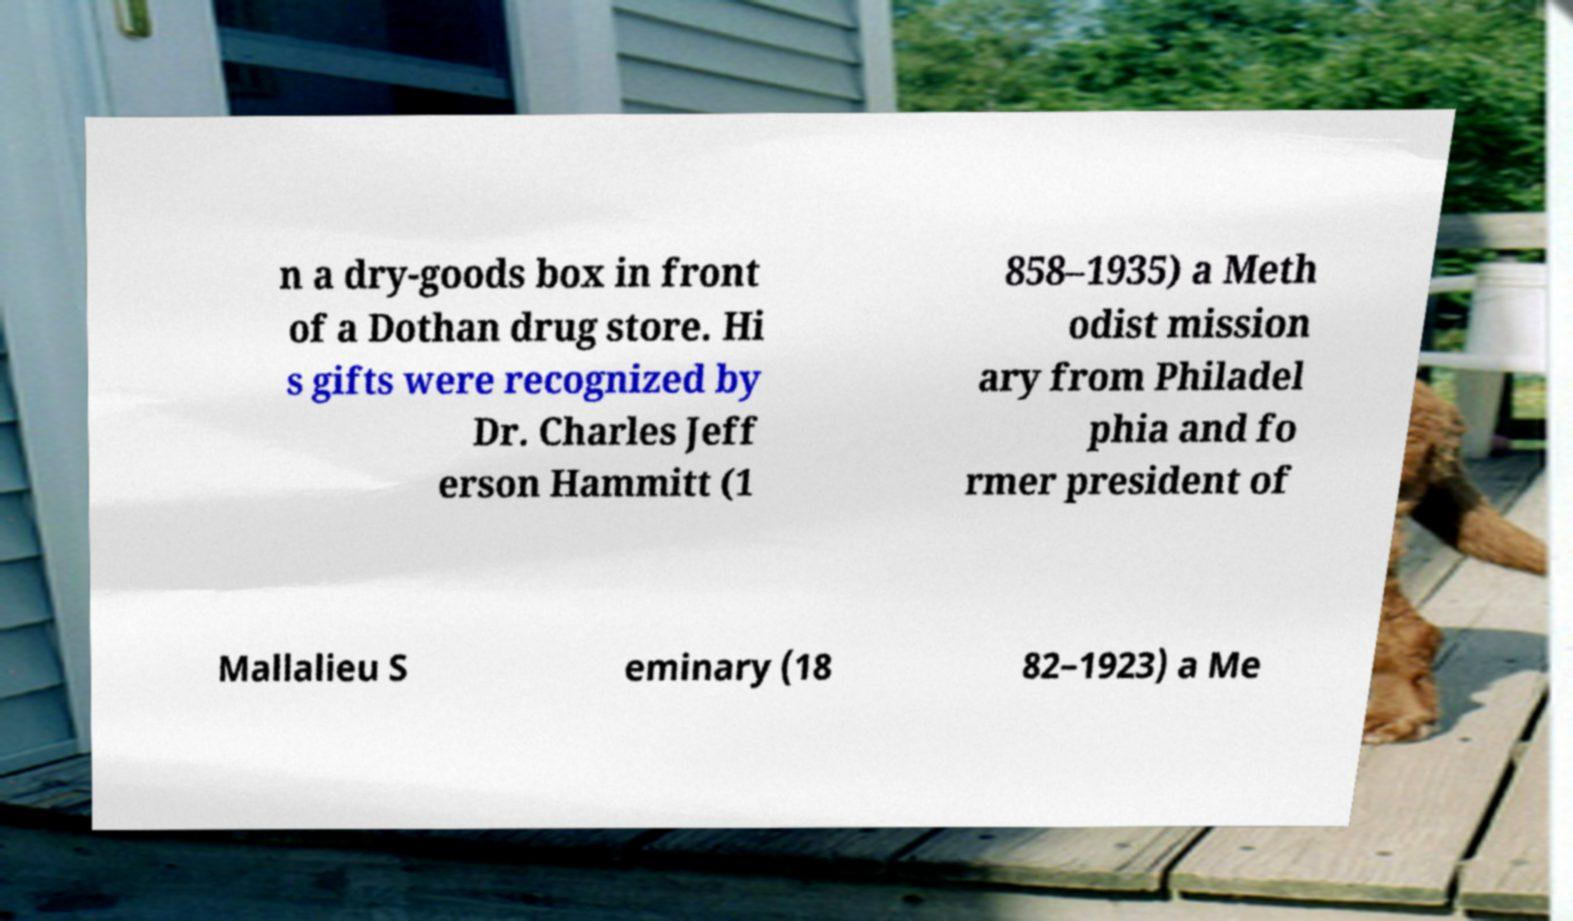Can you read and provide the text displayed in the image?This photo seems to have some interesting text. Can you extract and type it out for me? n a dry-goods box in front of a Dothan drug store. Hi s gifts were recognized by Dr. Charles Jeff erson Hammitt (1 858–1935) a Meth odist mission ary from Philadel phia and fo rmer president of Mallalieu S eminary (18 82–1923) a Me 